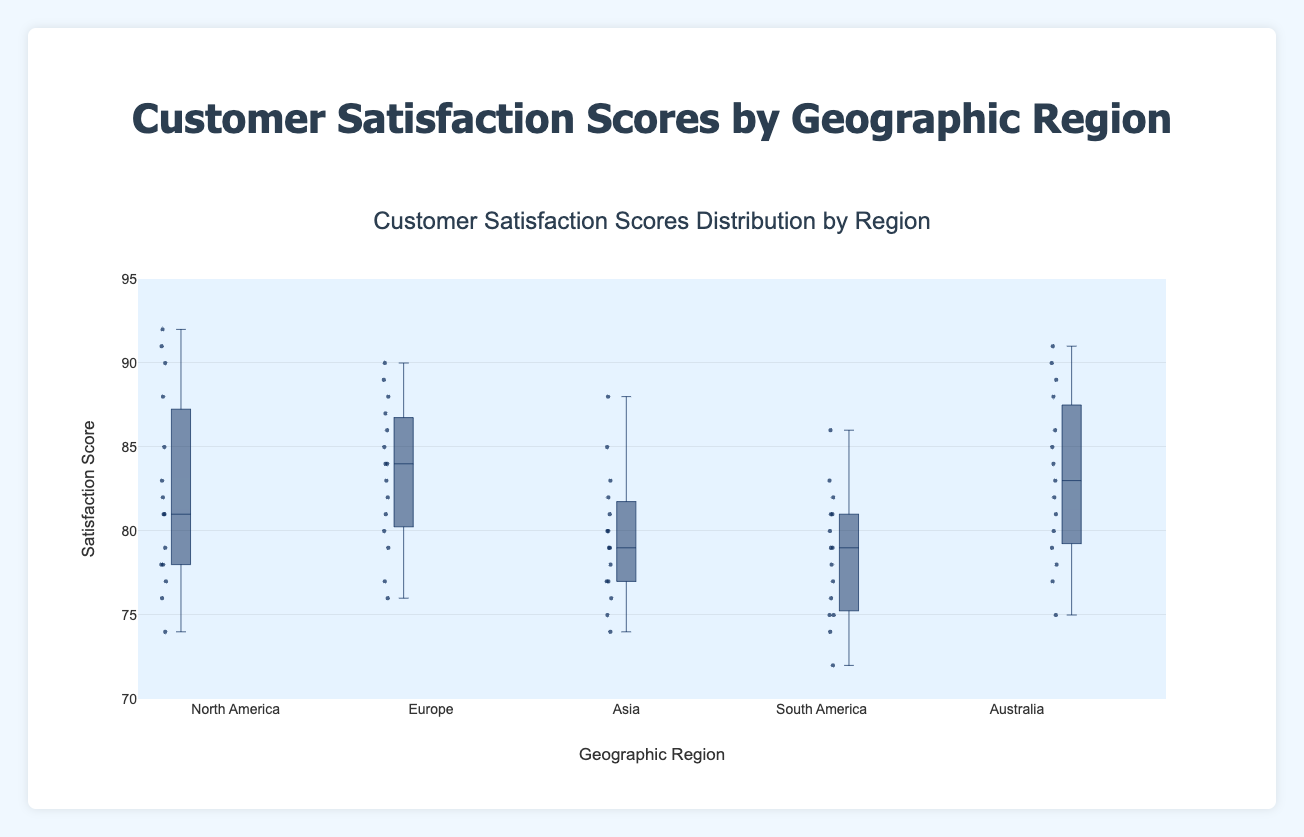What is the title of the plot? The title is usually located at the top of the figure and describes the main subject of the plot. In this case, it reads "Customer Satisfaction Scores Distribution by Region".
Answer: Customer Satisfaction Scores Distribution by Region What is the range of the y-axis? The range of the y-axis can be observed on the y-axis itself. In this figure, it ranges from 70 to 95.
Answer: 70 to 95 Which region has the highest median satisfaction score? The median is the middle value of the data set in each box plot. By observing the plots, we can see which box plot has the highest median line. In this case, the highest median line appears to be for "Australia".
Answer: Australia Which region has the most variability (largest interquartile range) in customer satisfaction scores? The variability or interquartile range (IQR) is the distance between the first and third quartiles (the bottom and top of the box). The region with the largest box is "North America".
Answer: North America What’s the median value of the customer satisfaction scores in North America? The median value is represented by the line inside the box of the box plot. For "North America", this median line is at 81.
Answer: 81 Which region has the lowest minimum satisfaction score? The minimum score can be identified by the lowest point in each box plot. "South America" has the lowest minimum satisfaction score at around 72.
Answer: South America What is the difference between the highest satisfaction scores in North America and Australia? To find this difference, observe the highest point (whisker) in both box plots. For North America, it is at 92, and for Australia, it is at 91. The difference is 92 - 91 = 1.
Answer: 1 What is the interquartile range (IQR) for Europe? The IQR is the distance between the third quartile (top of the box) and the first quartile (bottom of the box). For Europe, it ranges from about 79 to 87. Therefore, the IQR = 87 - 79 = 8.
Answer: 8 Which regions have an outlier below the 1st quartile? Outliers are points that fall outside the whiskers of the box plot. The box plots for "North America" and "Australia" both show points below their respective first quartiles.
Answer: North America, Australia 